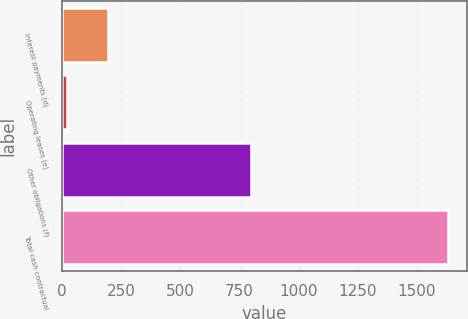Convert chart to OTSL. <chart><loc_0><loc_0><loc_500><loc_500><bar_chart><fcel>Interest payments (d)<fcel>Operating leases (e)<fcel>Other obligations (f)<fcel>Total cash contractual<nl><fcel>195<fcel>18<fcel>797<fcel>1630<nl></chart> 